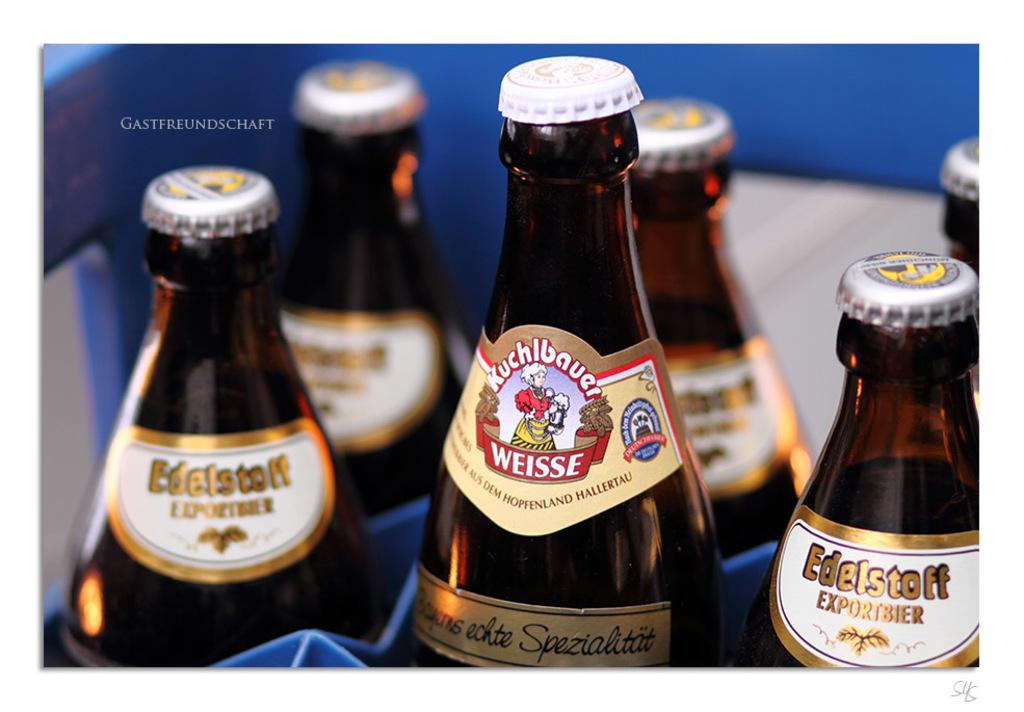<image>
Summarize the visual content of the image. A group of imported beer bottles include a Weisse. 